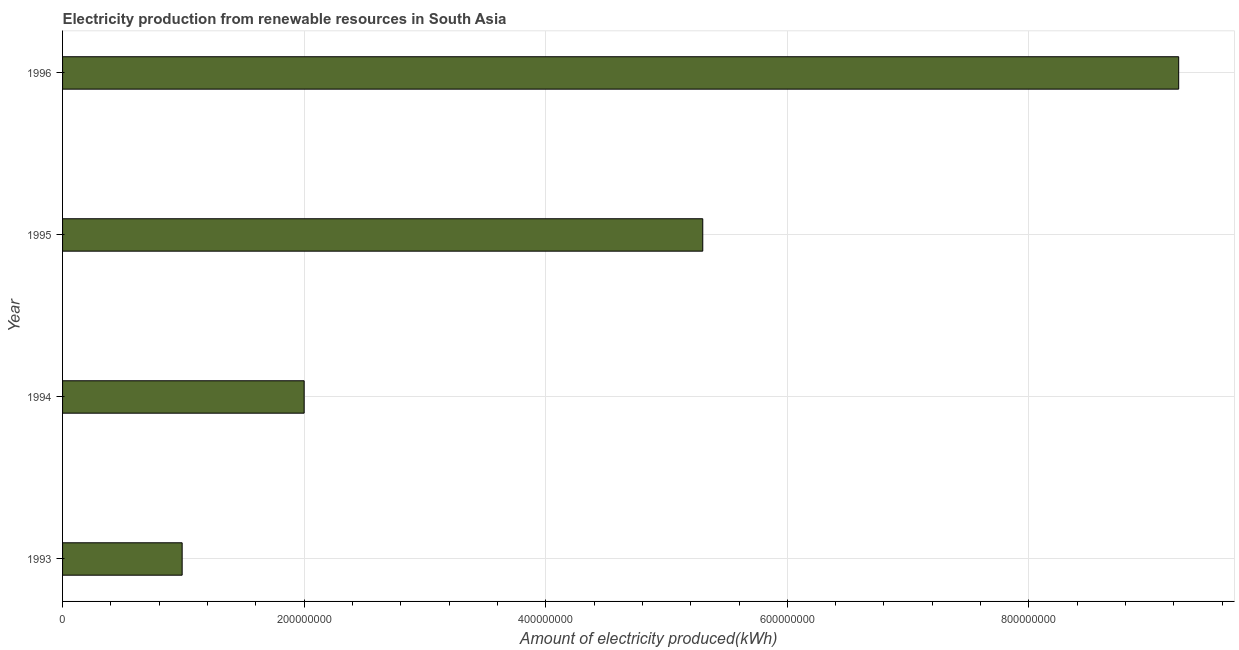Does the graph contain any zero values?
Your answer should be very brief. No. Does the graph contain grids?
Your answer should be very brief. Yes. What is the title of the graph?
Offer a very short reply. Electricity production from renewable resources in South Asia. What is the label or title of the X-axis?
Offer a very short reply. Amount of electricity produced(kWh). What is the amount of electricity produced in 1993?
Make the answer very short. 9.90e+07. Across all years, what is the maximum amount of electricity produced?
Keep it short and to the point. 9.24e+08. Across all years, what is the minimum amount of electricity produced?
Keep it short and to the point. 9.90e+07. In which year was the amount of electricity produced maximum?
Offer a terse response. 1996. In which year was the amount of electricity produced minimum?
Provide a succinct answer. 1993. What is the sum of the amount of electricity produced?
Your answer should be very brief. 1.75e+09. What is the difference between the amount of electricity produced in 1993 and 1996?
Make the answer very short. -8.25e+08. What is the average amount of electricity produced per year?
Your response must be concise. 4.38e+08. What is the median amount of electricity produced?
Make the answer very short. 3.65e+08. Do a majority of the years between 1993 and 1995 (inclusive) have amount of electricity produced greater than 400000000 kWh?
Ensure brevity in your answer.  No. What is the ratio of the amount of electricity produced in 1993 to that in 1995?
Provide a succinct answer. 0.19. Is the amount of electricity produced in 1993 less than that in 1996?
Give a very brief answer. Yes. Is the difference between the amount of electricity produced in 1993 and 1995 greater than the difference between any two years?
Offer a very short reply. No. What is the difference between the highest and the second highest amount of electricity produced?
Provide a short and direct response. 3.94e+08. Is the sum of the amount of electricity produced in 1993 and 1996 greater than the maximum amount of electricity produced across all years?
Ensure brevity in your answer.  Yes. What is the difference between the highest and the lowest amount of electricity produced?
Give a very brief answer. 8.25e+08. In how many years, is the amount of electricity produced greater than the average amount of electricity produced taken over all years?
Make the answer very short. 2. Are the values on the major ticks of X-axis written in scientific E-notation?
Ensure brevity in your answer.  No. What is the Amount of electricity produced(kWh) of 1993?
Give a very brief answer. 9.90e+07. What is the Amount of electricity produced(kWh) of 1995?
Keep it short and to the point. 5.30e+08. What is the Amount of electricity produced(kWh) of 1996?
Offer a very short reply. 9.24e+08. What is the difference between the Amount of electricity produced(kWh) in 1993 and 1994?
Offer a terse response. -1.01e+08. What is the difference between the Amount of electricity produced(kWh) in 1993 and 1995?
Your response must be concise. -4.31e+08. What is the difference between the Amount of electricity produced(kWh) in 1993 and 1996?
Offer a terse response. -8.25e+08. What is the difference between the Amount of electricity produced(kWh) in 1994 and 1995?
Provide a succinct answer. -3.30e+08. What is the difference between the Amount of electricity produced(kWh) in 1994 and 1996?
Your answer should be compact. -7.24e+08. What is the difference between the Amount of electricity produced(kWh) in 1995 and 1996?
Ensure brevity in your answer.  -3.94e+08. What is the ratio of the Amount of electricity produced(kWh) in 1993 to that in 1994?
Give a very brief answer. 0.49. What is the ratio of the Amount of electricity produced(kWh) in 1993 to that in 1995?
Provide a short and direct response. 0.19. What is the ratio of the Amount of electricity produced(kWh) in 1993 to that in 1996?
Keep it short and to the point. 0.11. What is the ratio of the Amount of electricity produced(kWh) in 1994 to that in 1995?
Give a very brief answer. 0.38. What is the ratio of the Amount of electricity produced(kWh) in 1994 to that in 1996?
Offer a very short reply. 0.22. What is the ratio of the Amount of electricity produced(kWh) in 1995 to that in 1996?
Offer a terse response. 0.57. 